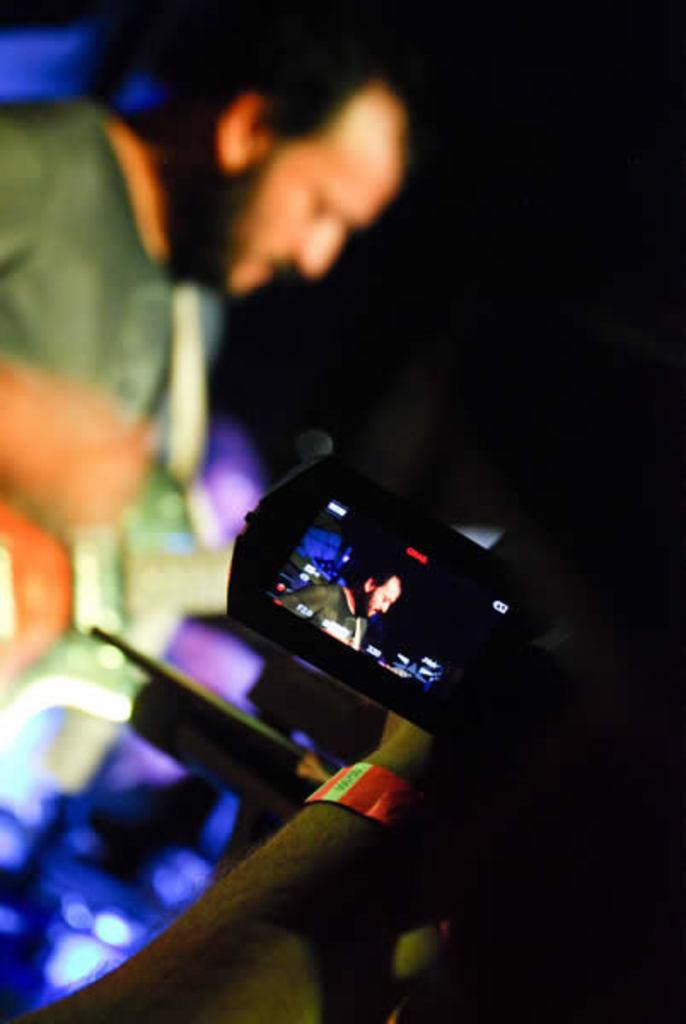What is visible on the person's hand in the image? There is a person's hand with a band in the image. What is the person holding in the image? The person is holding a camera. What activity is taking place in the background of the image? There is a person playing the guitar in the background of the image. What type of pin is the person wearing on their shirt in the image? There is no pin visible on the person's shirt in the image. What kind of doll is sitting on the guitar in the image? There is no doll present in the image; it features a person playing the guitar. 